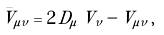<formula> <loc_0><loc_0><loc_500><loc_500>\bar { V } _ { \mu \nu } = 2 \, D _ { \mu } \, V _ { \nu } - V _ { \mu \nu } \, ,</formula> 